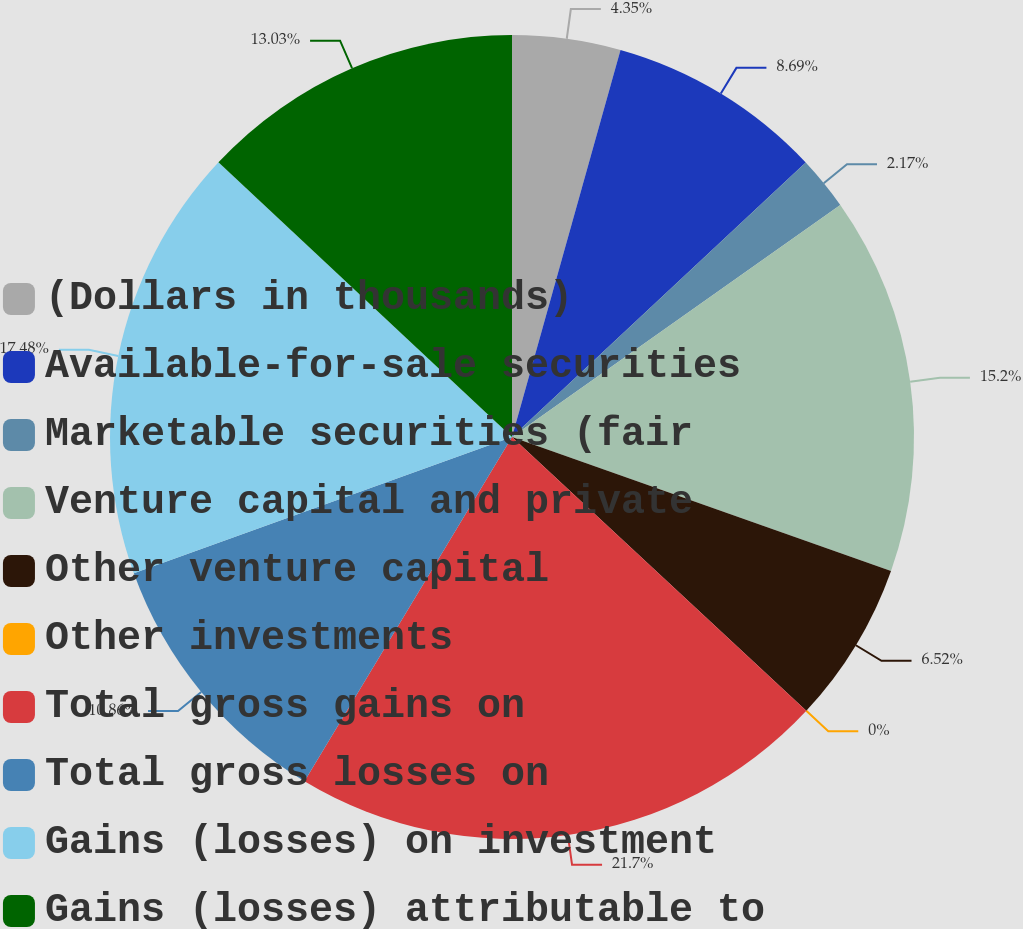Convert chart to OTSL. <chart><loc_0><loc_0><loc_500><loc_500><pie_chart><fcel>(Dollars in thousands)<fcel>Available-for-sale securities<fcel>Marketable securities (fair<fcel>Venture capital and private<fcel>Other venture capital<fcel>Other investments<fcel>Total gross gains on<fcel>Total gross losses on<fcel>Gains (losses) on investment<fcel>Gains (losses) attributable to<nl><fcel>4.35%<fcel>8.69%<fcel>2.17%<fcel>15.2%<fcel>6.52%<fcel>0.0%<fcel>21.71%<fcel>10.86%<fcel>17.48%<fcel>13.03%<nl></chart> 